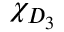<formula> <loc_0><loc_0><loc_500><loc_500>\chi _ { D _ { 3 } }</formula> 